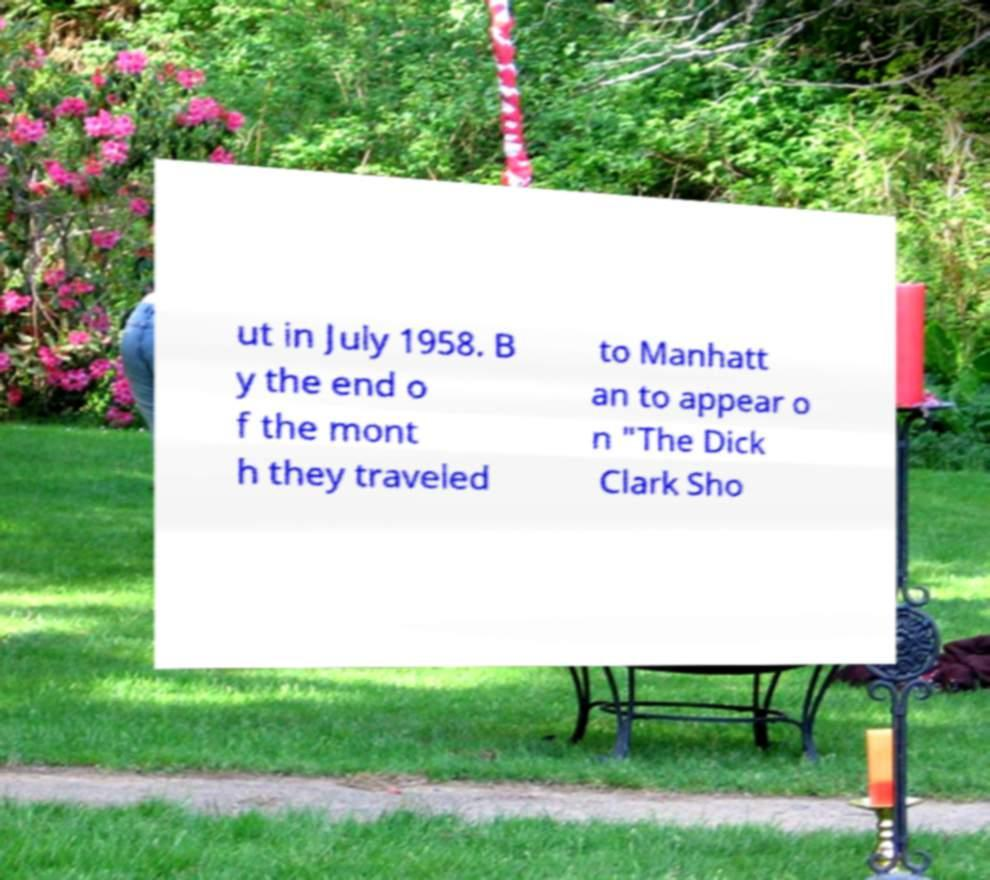Please identify and transcribe the text found in this image. ut in July 1958. B y the end o f the mont h they traveled to Manhatt an to appear o n "The Dick Clark Sho 